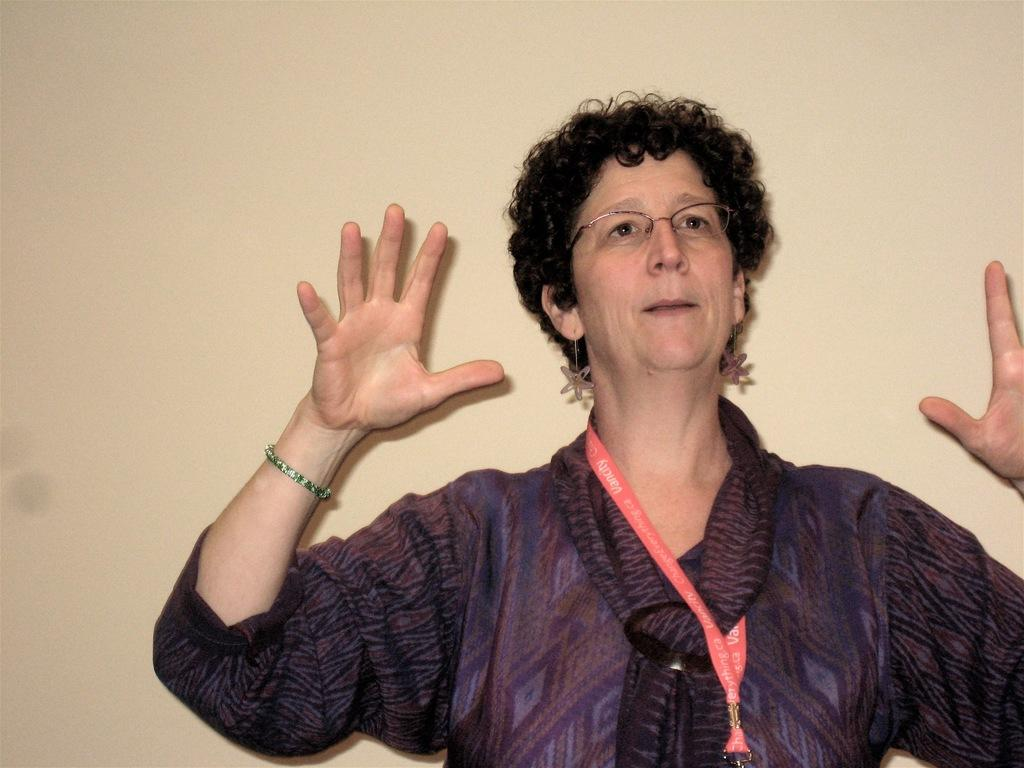Who or what is the main subject in the front of the image? There is a person in the front of the image. What can be observed about the person's appearance? The person is wearing spectacles. What can be seen in the background of the image? There is a wall in the background of the image. How many pies are on the wall in the image? There are no pies present in the image; the wall is the only background element mentioned. 